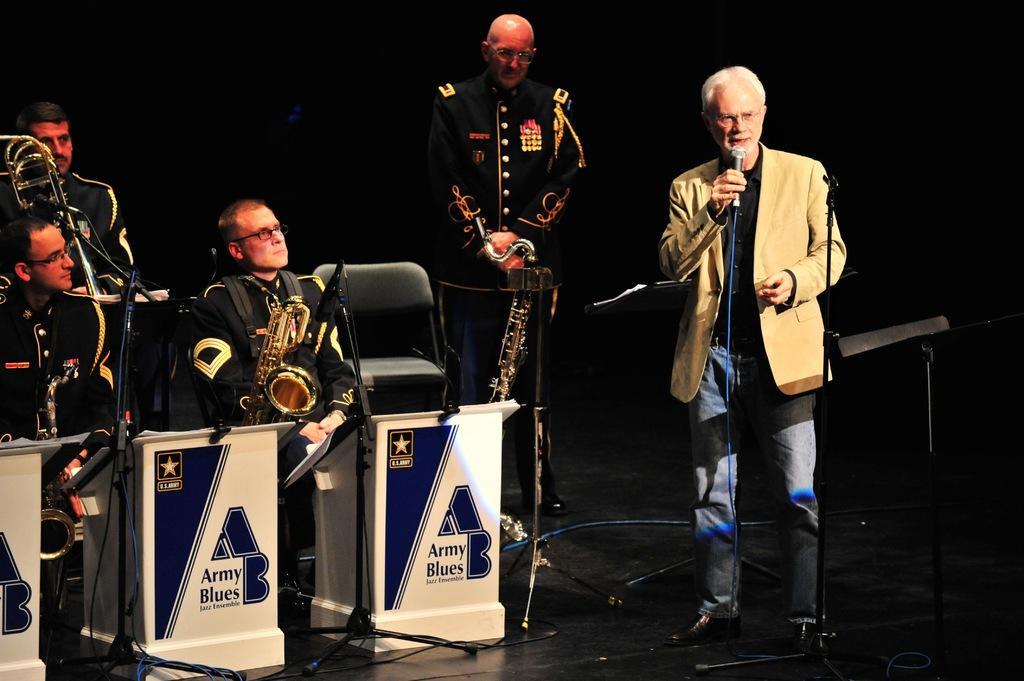Please provide a concise description of this image. In this picture we can see five people where three are sitting on chairs and two are standing, mics, stands, saxophones, wires and in the background it is dark. 